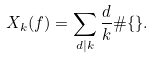Convert formula to latex. <formula><loc_0><loc_0><loc_500><loc_500>X _ { k } ( f ) = \sum _ { d | k } \frac { d } { k } \# \{ \} .</formula> 